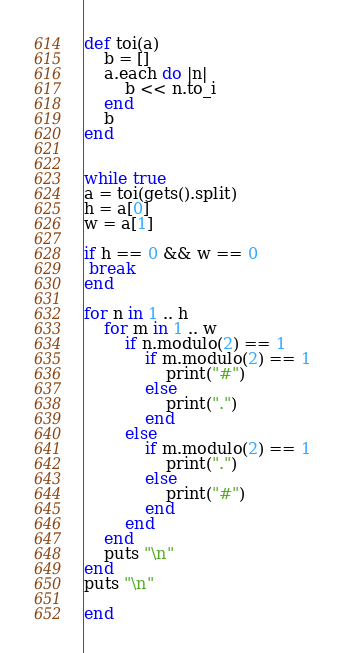Convert code to text. <code><loc_0><loc_0><loc_500><loc_500><_Ruby_>def toi(a)
	b = []
	a.each do |n|
		b << n.to_i
	end
	b	
end


while true
a = toi(gets().split)
h = a[0]
w = a[1]

if h == 0 && w == 0
 break
end

for n in 1 .. h
	for m in 1 .. w
		if n.modulo(2) == 1
			if m.modulo(2) == 1
				print("#")
			else
				print(".")
			end
		else
			if m.modulo(2) == 1
				print(".")
			else
				print("#")
			end
		end
	end
	puts "\n"
end
puts "\n"

end</code> 